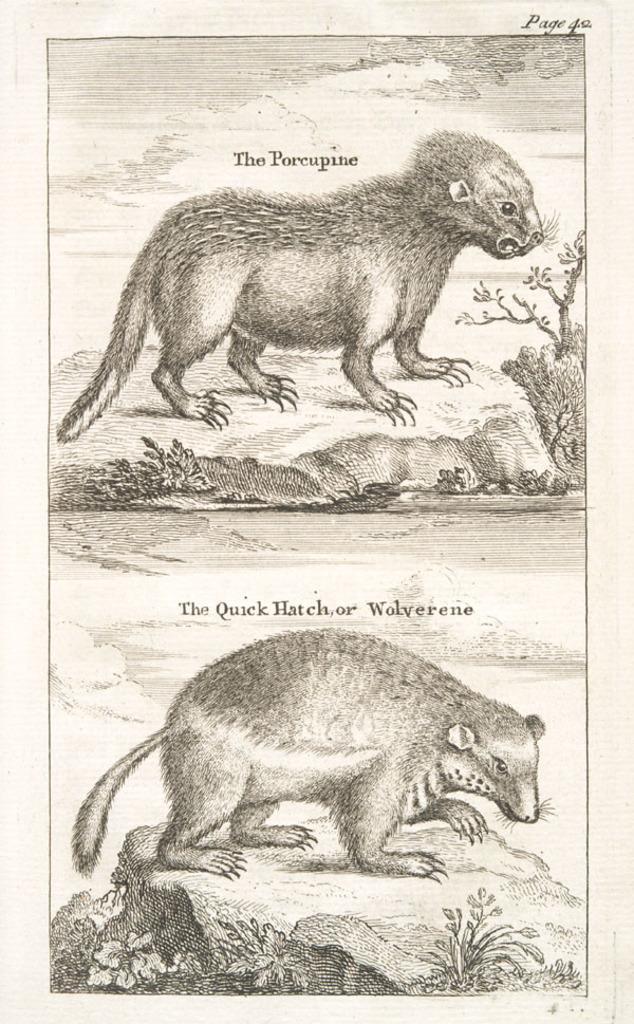Could you give a brief overview of what you see in this image? In this image, we can see a picture, in that picture we can see two animals. 